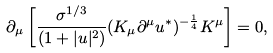Convert formula to latex. <formula><loc_0><loc_0><loc_500><loc_500>\partial _ { \mu } \left [ \frac { \sigma ^ { 1 / 3 } } { ( 1 + | u | ^ { 2 } ) } ( K _ { \mu } \partial ^ { \mu } u ^ { * } ) ^ { - \frac { 1 } { 4 } } K ^ { \mu } \right ] = 0 ,</formula> 